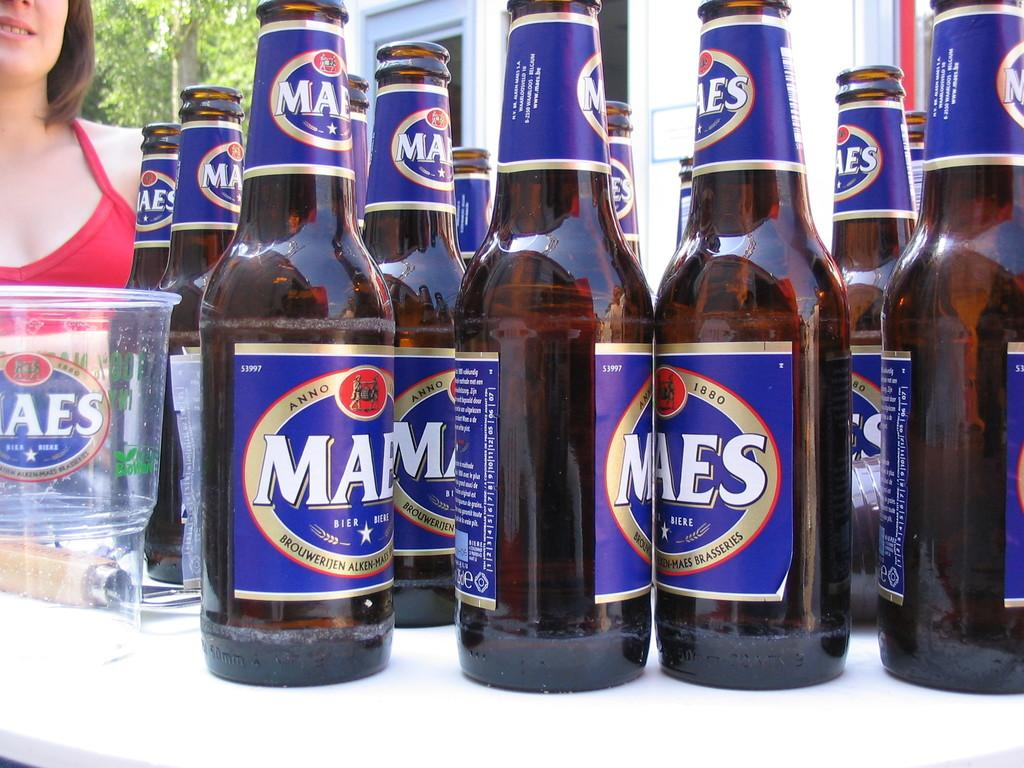Provide a one-sentence caption for the provided image. Eleven bottles of Maes beer Brouwerijen alken-maes brasseries. 